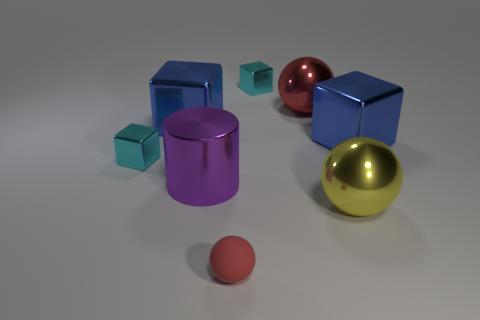Subtract all red balls. How many balls are left? 1 Add 1 small brown cubes. How many objects exist? 9 Subtract all blue blocks. How many blocks are left? 2 Subtract all balls. How many objects are left? 5 Subtract 1 cylinders. How many cylinders are left? 0 Subtract all gray cubes. How many red balls are left? 2 Add 5 rubber spheres. How many rubber spheres are left? 6 Add 1 big purple metal cylinders. How many big purple metal cylinders exist? 2 Subtract 0 gray spheres. How many objects are left? 8 Subtract all cyan spheres. Subtract all cyan cylinders. How many spheres are left? 3 